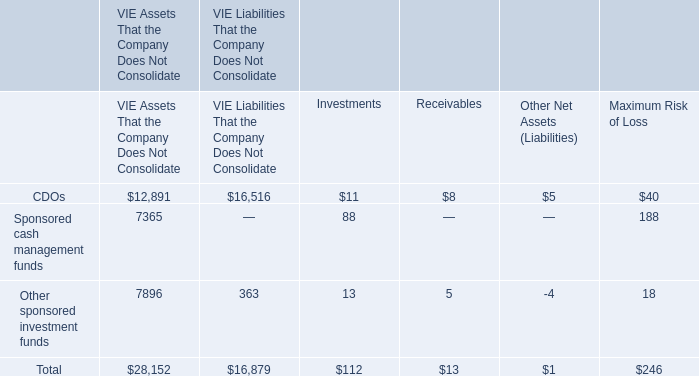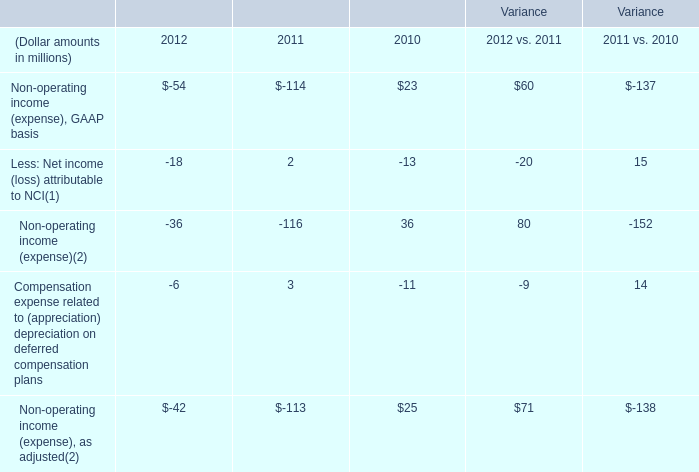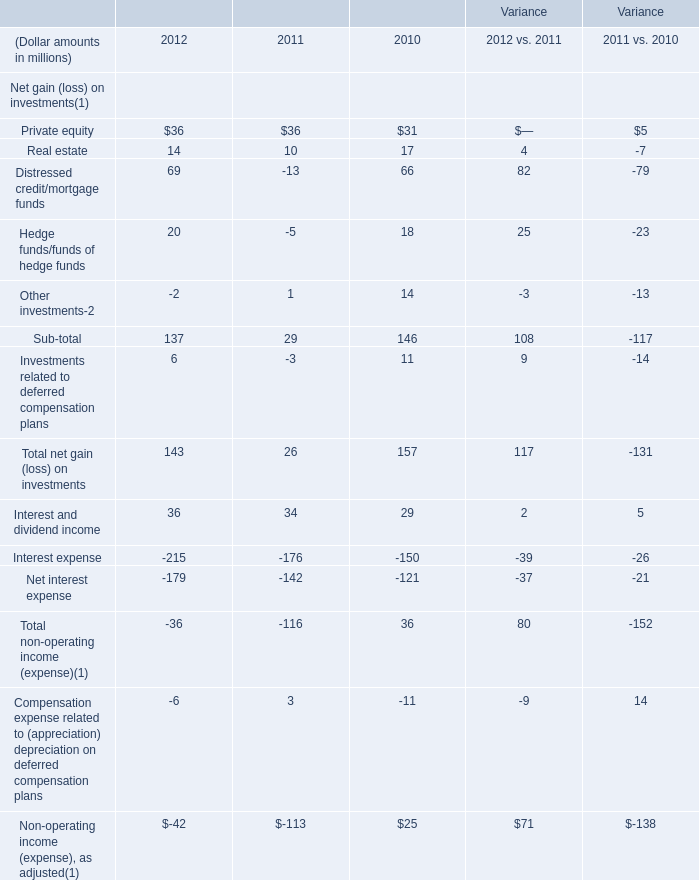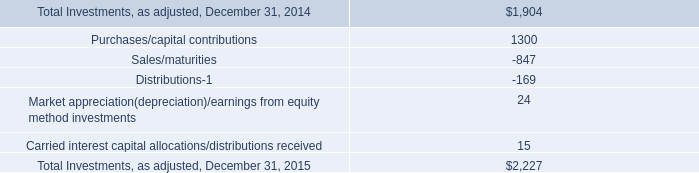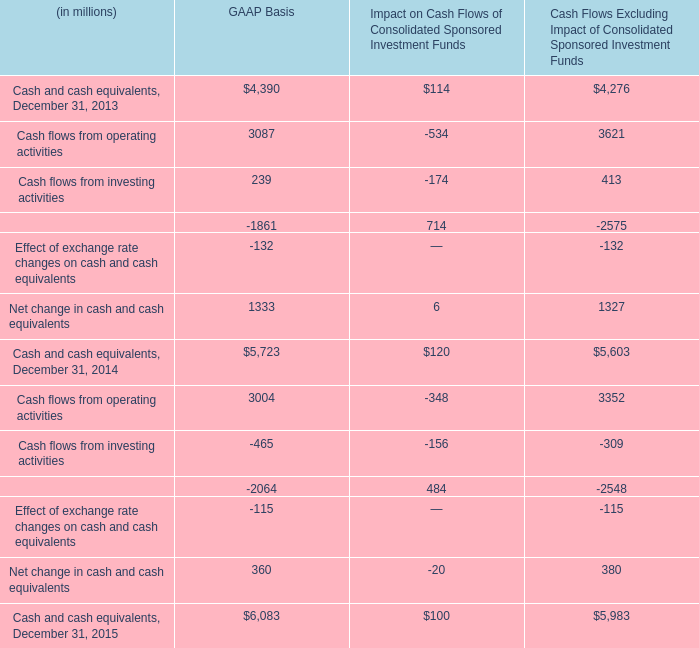In which year is Non-operating income (expense), GAAP basis positive? 
Answer: 2010 2012 vs. 2011. 